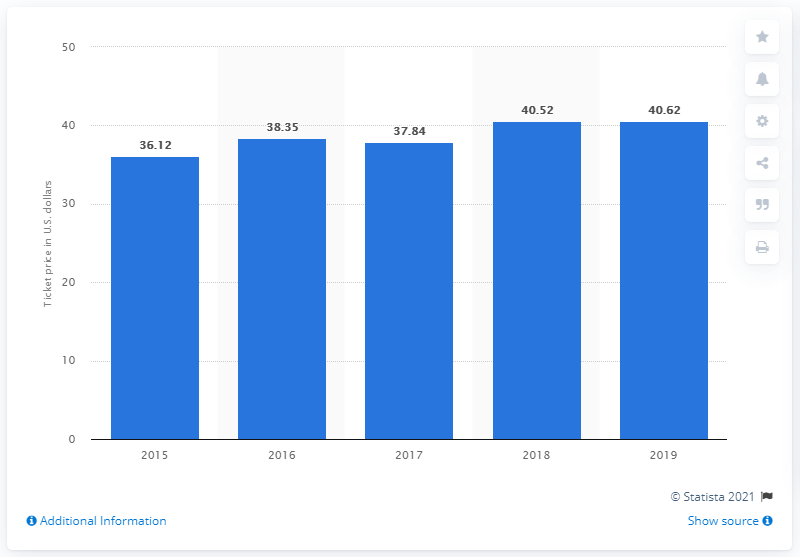Point out several critical features in this image. The average price of a non-profit theater ticket in 2015 was $36.12. The average single-ticket price in non-profit theaters in the United States increased in 2015. The average price of a single ticket in 2019 was 40.62 dollars. 